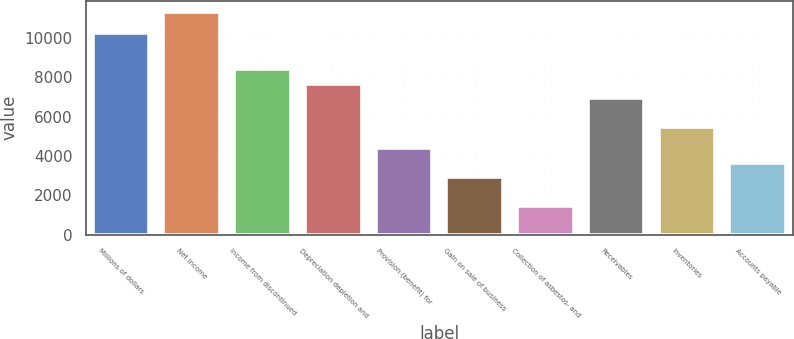Convert chart. <chart><loc_0><loc_0><loc_500><loc_500><bar_chart><fcel>Millions of dollars<fcel>Net income<fcel>Income from discontinued<fcel>Depreciation depletion and<fcel>Provision (benefit) for<fcel>Gain on sale of business<fcel>Collection of asbestos- and<fcel>Receivables<fcel>Inventories<fcel>Accounts payable<nl><fcel>10241.8<fcel>11338.6<fcel>8413.8<fcel>7682.6<fcel>4392.2<fcel>2929.8<fcel>1467.4<fcel>6951.4<fcel>5489<fcel>3661<nl></chart> 